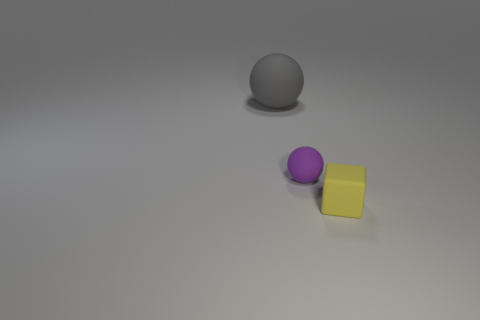Are any yellow matte things visible?
Your answer should be very brief. Yes. Do the gray object and the sphere to the right of the gray matte sphere have the same material?
Your answer should be very brief. Yes. There is a cube that is the same size as the purple rubber object; what material is it?
Offer a terse response. Rubber. Are there any small purple cylinders that have the same material as the purple sphere?
Your answer should be very brief. No. Are there any tiny matte things that are behind the tiny rubber thing right of the matte sphere on the right side of the big gray rubber ball?
Your answer should be very brief. Yes. The other object that is the same size as the yellow object is what shape?
Offer a terse response. Sphere. There is a thing on the right side of the small purple thing; is its size the same as the matte object that is behind the tiny purple thing?
Give a very brief answer. No. What number of big green shiny blocks are there?
Your answer should be compact. 0. There is a rubber thing that is left of the tiny matte thing that is behind the small thing right of the small purple rubber thing; what is its size?
Offer a terse response. Large. Does the tiny rubber sphere have the same color as the matte cube?
Offer a very short reply. No. 